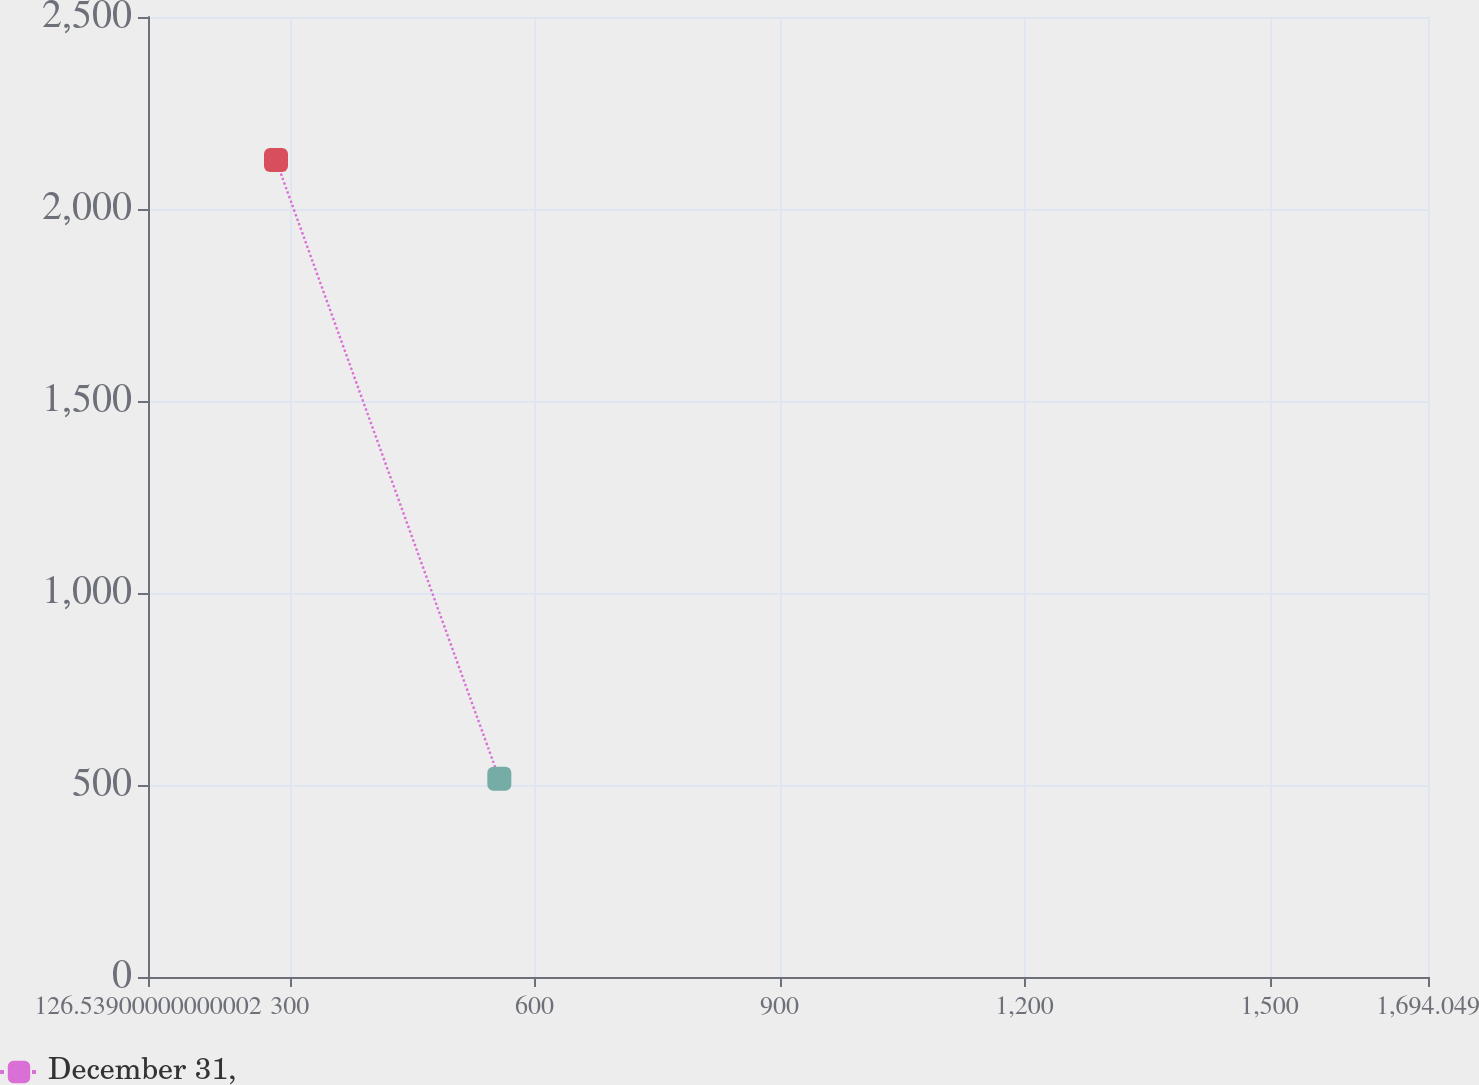<chart> <loc_0><loc_0><loc_500><loc_500><line_chart><ecel><fcel>December 31,<nl><fcel>283.29<fcel>2127.47<nl><fcel>556.8<fcel>516.13<nl><fcel>1850.8<fcel>294.79<nl></chart> 